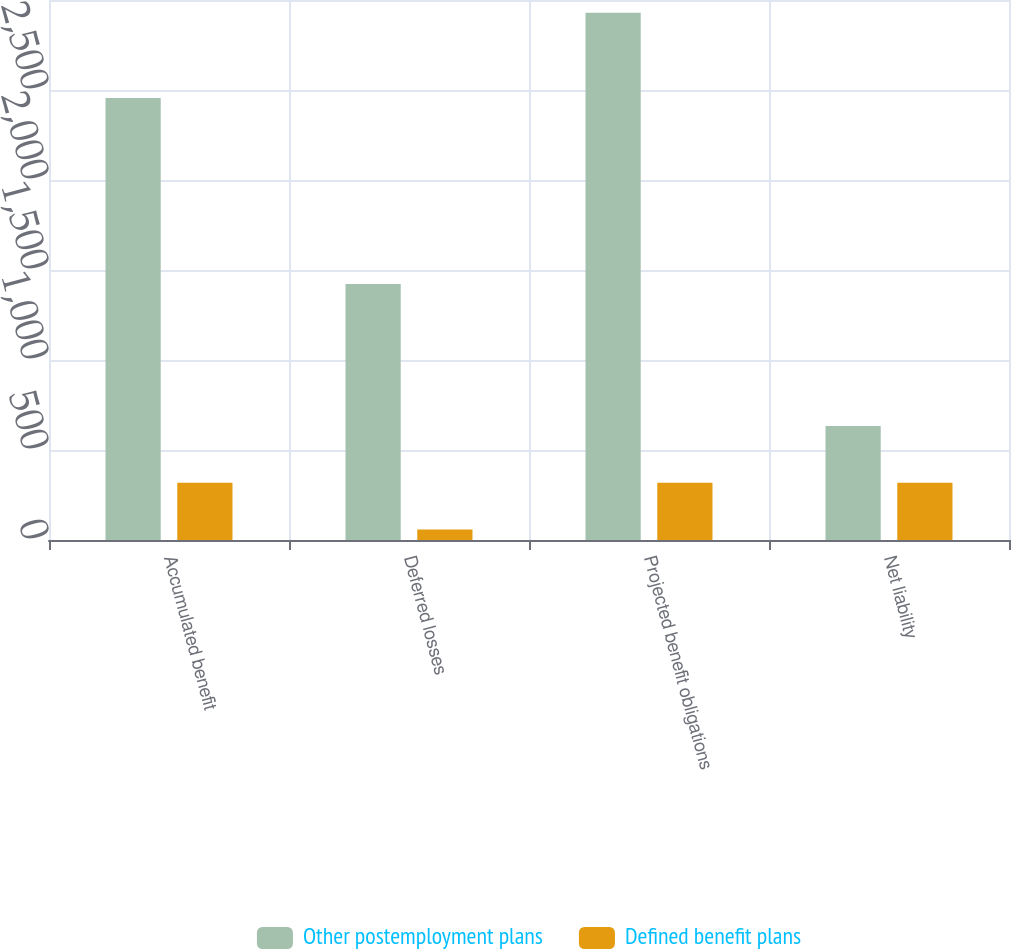Convert chart to OTSL. <chart><loc_0><loc_0><loc_500><loc_500><stacked_bar_chart><ecel><fcel>Accumulated benefit<fcel>Deferred losses<fcel>Projected benefit obligations<fcel>Net liability<nl><fcel>Other postemployment plans<fcel>2456<fcel>1422<fcel>2929<fcel>634<nl><fcel>Defined benefit plans<fcel>318<fcel>59<fcel>318<fcel>318<nl></chart> 